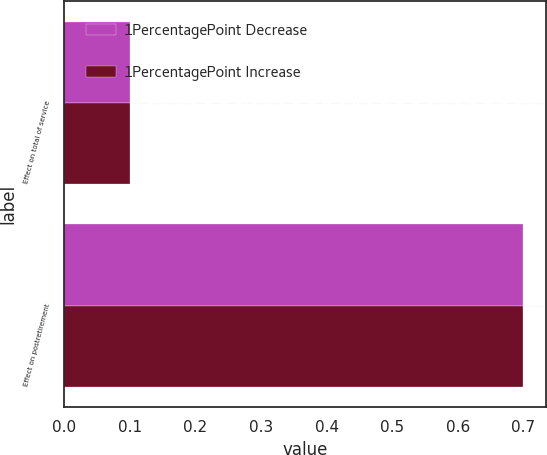Convert chart to OTSL. <chart><loc_0><loc_0><loc_500><loc_500><stacked_bar_chart><ecel><fcel>Effect on total of service<fcel>Effect on postretirement<nl><fcel>1PercentagePoint Decrease<fcel>0.1<fcel>0.7<nl><fcel>1PercentagePoint Increase<fcel>0.1<fcel>0.7<nl></chart> 